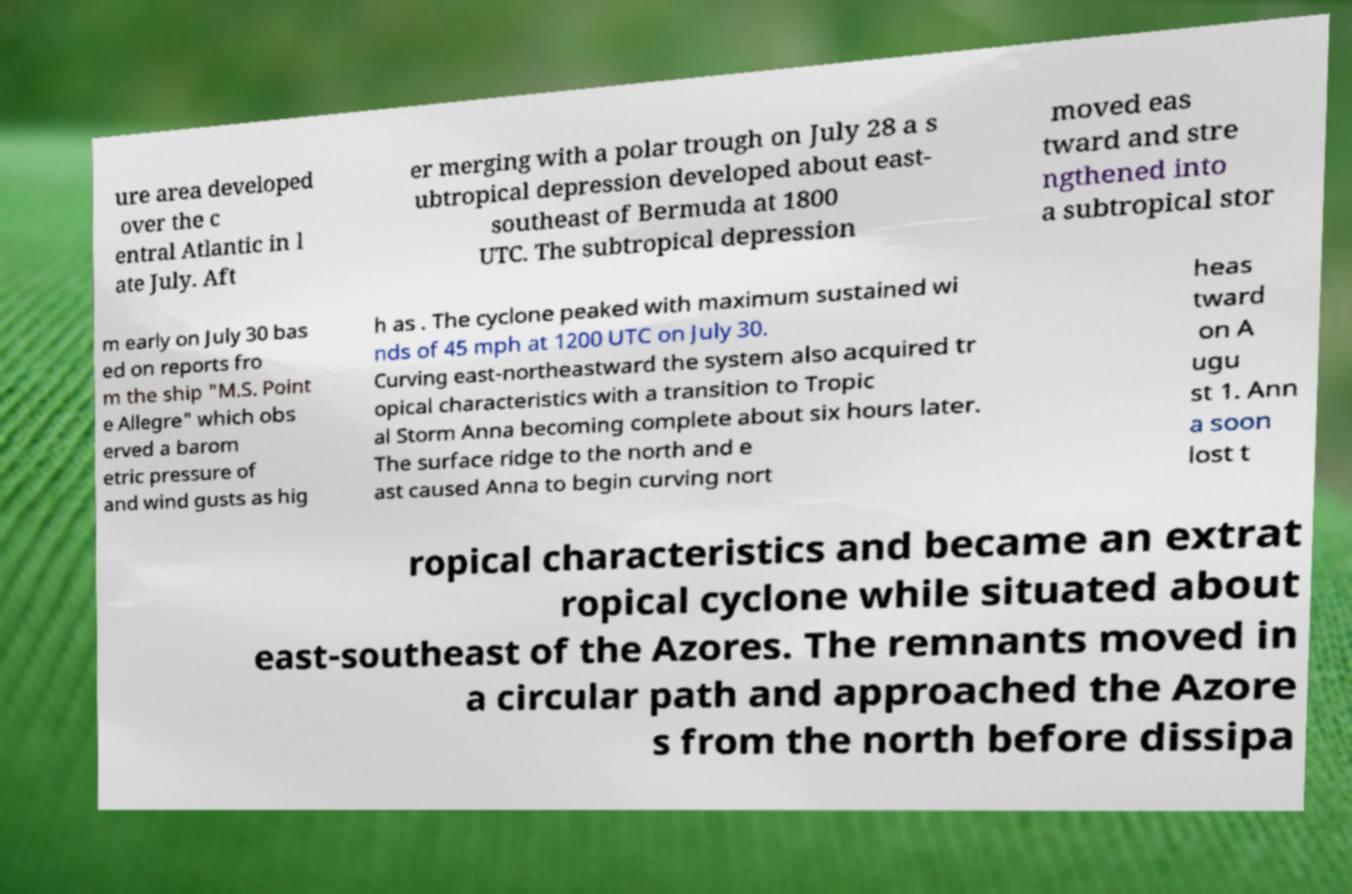I need the written content from this picture converted into text. Can you do that? ure area developed over the c entral Atlantic in l ate July. Aft er merging with a polar trough on July 28 a s ubtropical depression developed about east- southeast of Bermuda at 1800 UTC. The subtropical depression moved eas tward and stre ngthened into a subtropical stor m early on July 30 bas ed on reports fro m the ship "M.S. Point e Allegre" which obs erved a barom etric pressure of and wind gusts as hig h as . The cyclone peaked with maximum sustained wi nds of 45 mph at 1200 UTC on July 30. Curving east-northeastward the system also acquired tr opical characteristics with a transition to Tropic al Storm Anna becoming complete about six hours later. The surface ridge to the north and e ast caused Anna to begin curving nort heas tward on A ugu st 1. Ann a soon lost t ropical characteristics and became an extrat ropical cyclone while situated about east-southeast of the Azores. The remnants moved in a circular path and approached the Azore s from the north before dissipa 